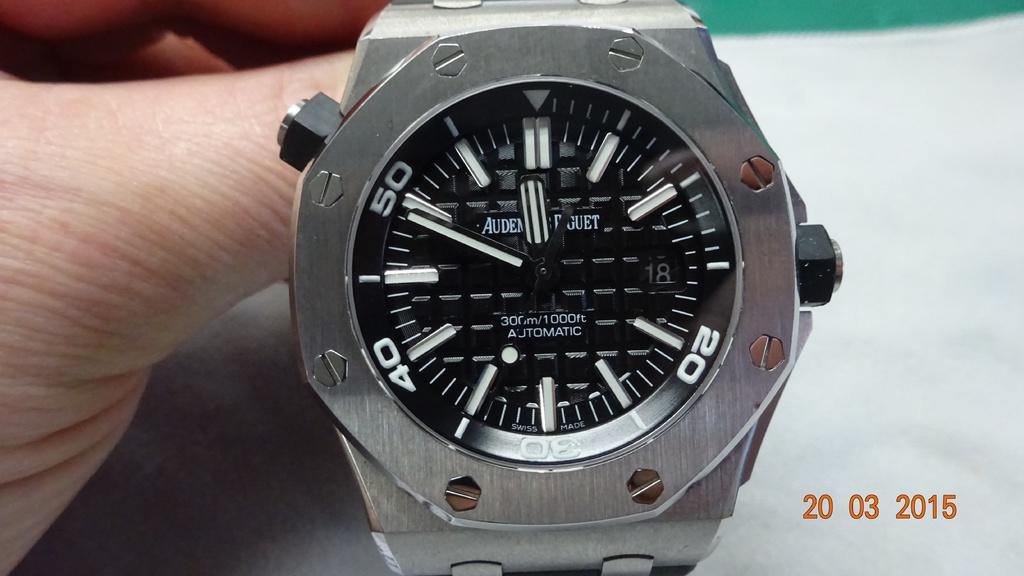<image>
Write a terse but informative summary of the picture. A watch with the number 20 on it being held up by a hand. 